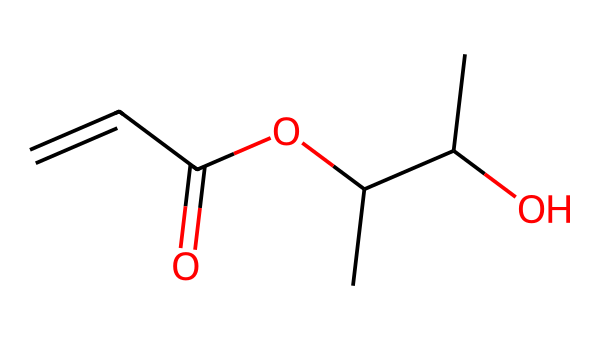How many carbon atoms are in this chemical? By examining the SMILES representation, we count the carbon (C) atoms present in the structure. The chemical has six carbon atoms indicated by the Count in the SMILES sequence.
Answer: 6 What functional groups are identified in this structure? The structure contains multiple functional groups, particularly a hydroxyl (-OH) group indicated by CC(O), and a carbonyl (C=O) group seen in OC(=O). This indicates the presence of an alcohol and a carboxylic acid.
Answer: alcohol, carboxylic acid What type of bond connects carbon atoms in this chemical? In the given SMILES, the carbon atoms are primarily connected by single covalent bonds; however, there is also a double bond between two carbon atoms noted in C=C.
Answer: single, double Which part of the molecule is likely responsible for UV light sensitivity? Photoresists are designed to change properties upon exposure to UV light. Typically, the vinyl (C=C) part of the molecule is responsible for undergoing polymerization when exposed to UV radiation.
Answer: vinyl group What is the overall saturation of this molecule? By analyzing the structure based on the number of hydrogen atoms attached to each carbon relative to their bonds, it can be determined that the molecule is unsaturated due to the presence of a double bond (C=C) reducing the number of hydrogen atoms.
Answer: unsaturated How does this molecule likely engage with light in photolithography? The presence of the double bond (C=C) in the structure allows for the reaction needed for photolithography. When exposed to light, this bond can undergo a reaction such as cross-linking, which is crucial in photoresist application.
Answer: reacts through cross-linking 